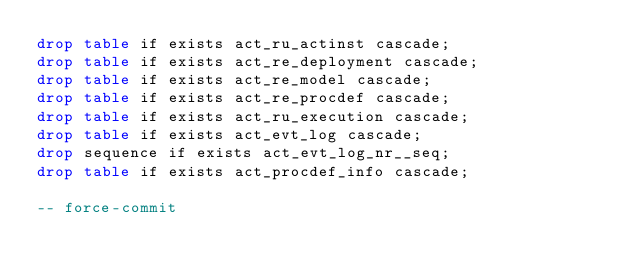<code> <loc_0><loc_0><loc_500><loc_500><_SQL_>drop table if exists act_ru_actinst cascade;
drop table if exists act_re_deployment cascade;
drop table if exists act_re_model cascade;
drop table if exists act_re_procdef cascade;
drop table if exists act_ru_execution cascade;
drop table if exists act_evt_log cascade;
drop sequence if exists act_evt_log_nr__seq;
drop table if exists act_procdef_info cascade;

-- force-commit</code> 